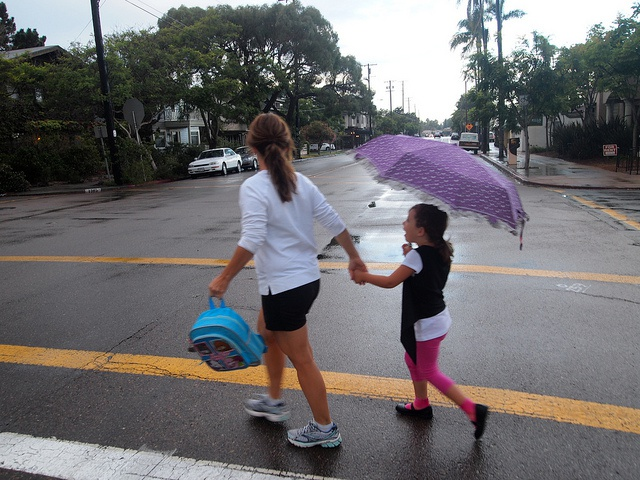Describe the objects in this image and their specific colors. I can see people in lightblue, darkgray, black, and maroon tones, people in lightblue, black, maroon, darkgray, and gray tones, umbrella in lightblue, gray, and purple tones, backpack in lightblue, blue, teal, and black tones, and car in lightblue, black, gray, lightgray, and darkgray tones in this image. 